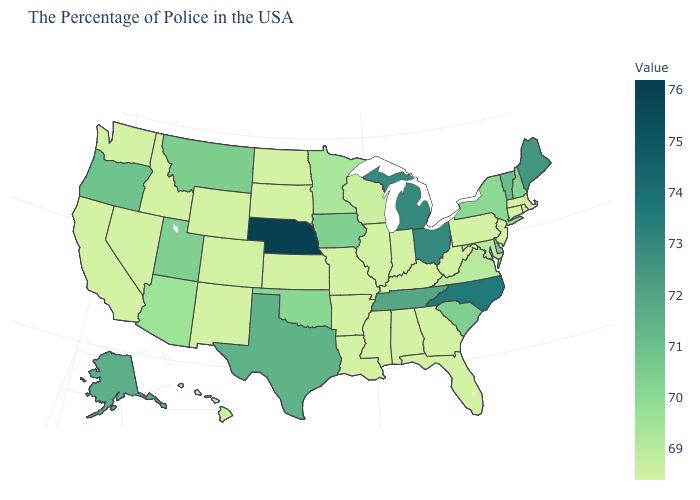Does Texas have a lower value than Wisconsin?
Write a very short answer. No. Does Maine have the highest value in the Northeast?
Keep it brief. Yes. Does Wisconsin have the highest value in the USA?
Keep it brief. No. Does Minnesota have the lowest value in the USA?
Concise answer only. No. 